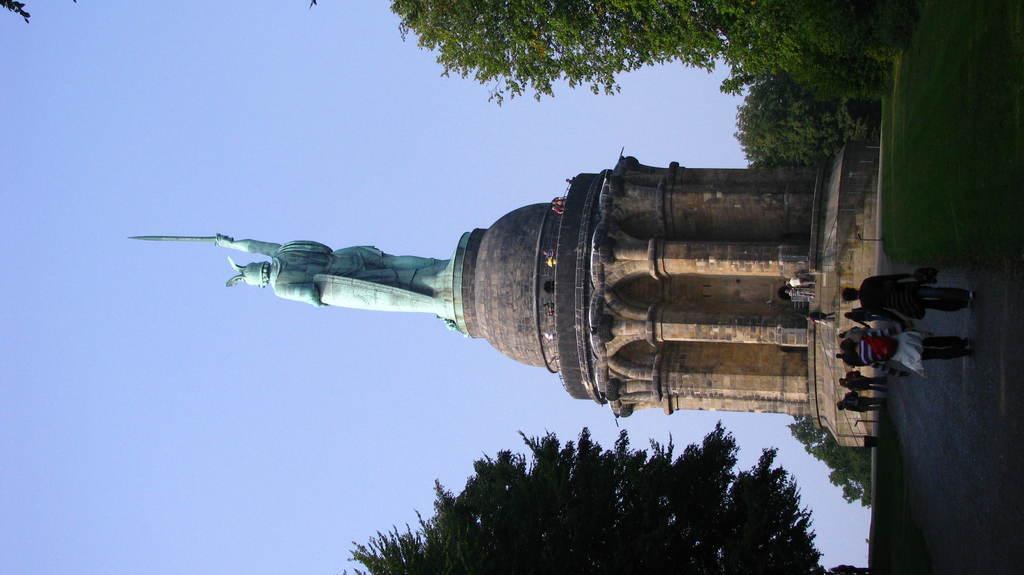Could you give a brief overview of what you see in this image? In this image at the center people are walking on the road. In front of them there is a status. On both right and left side of the image there are trees. There is grass on the surface. At the top of the image there is sky. 